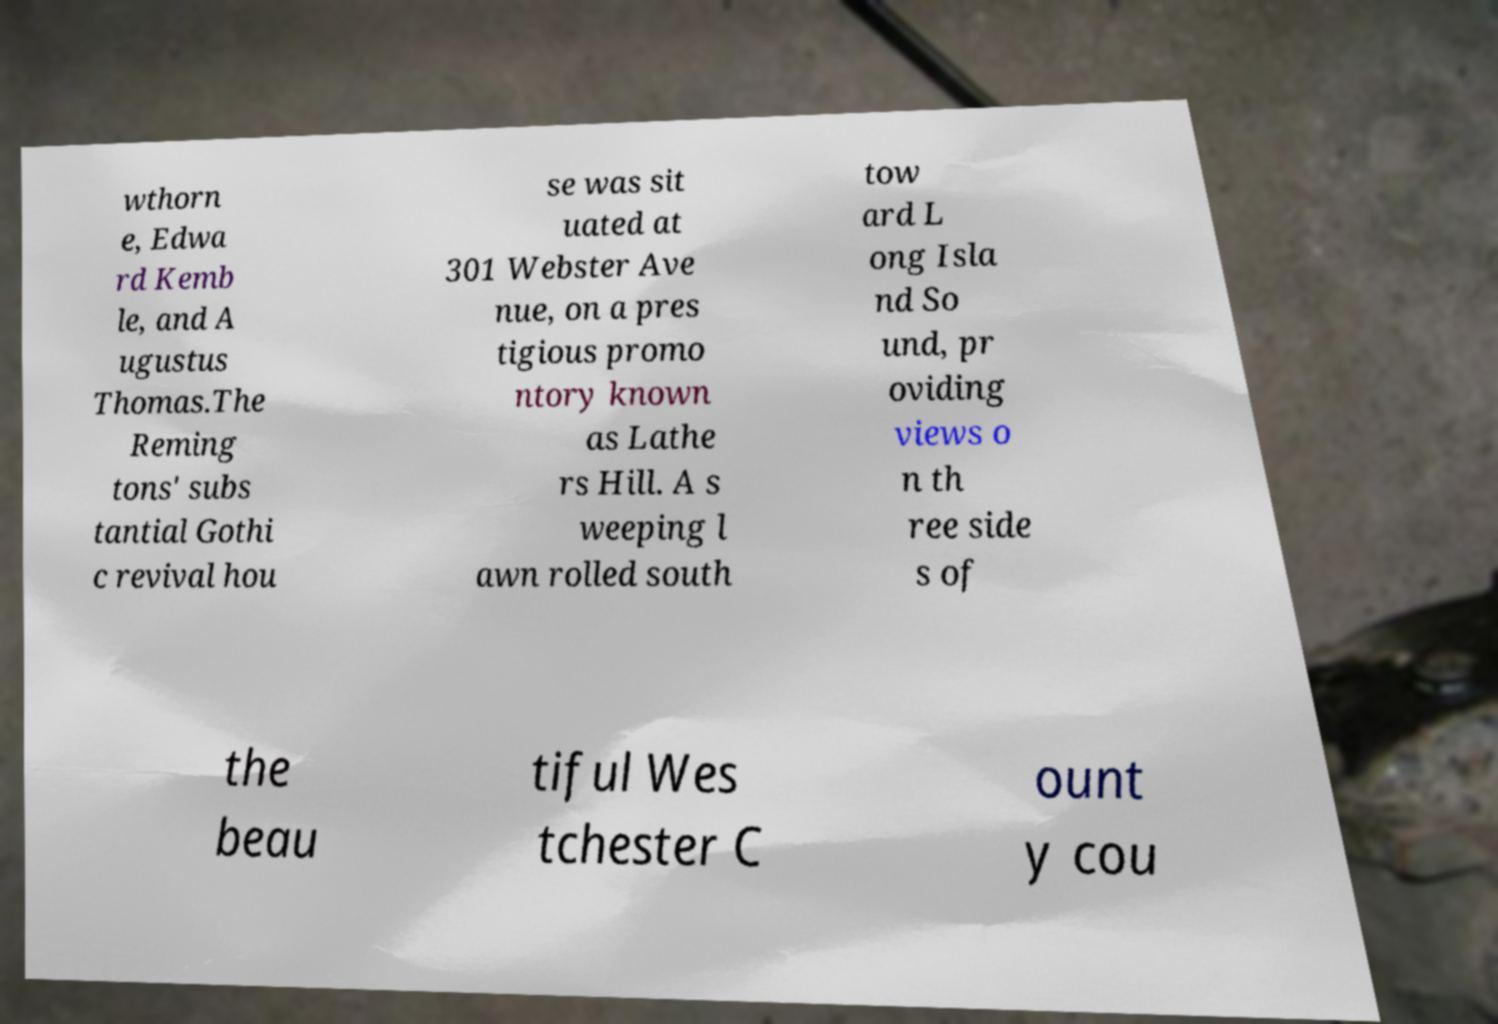Please identify and transcribe the text found in this image. wthorn e, Edwa rd Kemb le, and A ugustus Thomas.The Reming tons' subs tantial Gothi c revival hou se was sit uated at 301 Webster Ave nue, on a pres tigious promo ntory known as Lathe rs Hill. A s weeping l awn rolled south tow ard L ong Isla nd So und, pr oviding views o n th ree side s of the beau tiful Wes tchester C ount y cou 